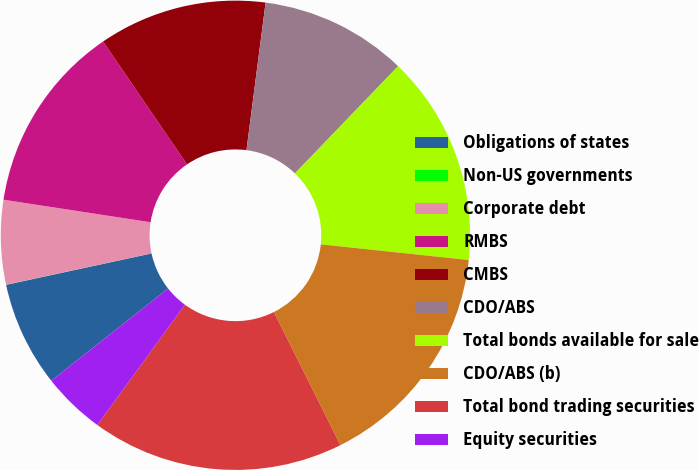Convert chart. <chart><loc_0><loc_0><loc_500><loc_500><pie_chart><fcel>Obligations of states<fcel>Non-US governments<fcel>Corporate debt<fcel>RMBS<fcel>CMBS<fcel>CDO/ABS<fcel>Total bonds available for sale<fcel>CDO/ABS (b)<fcel>Total bond trading securities<fcel>Equity securities<nl><fcel>7.25%<fcel>0.01%<fcel>5.8%<fcel>13.04%<fcel>11.59%<fcel>10.14%<fcel>14.49%<fcel>15.94%<fcel>17.39%<fcel>4.35%<nl></chart> 